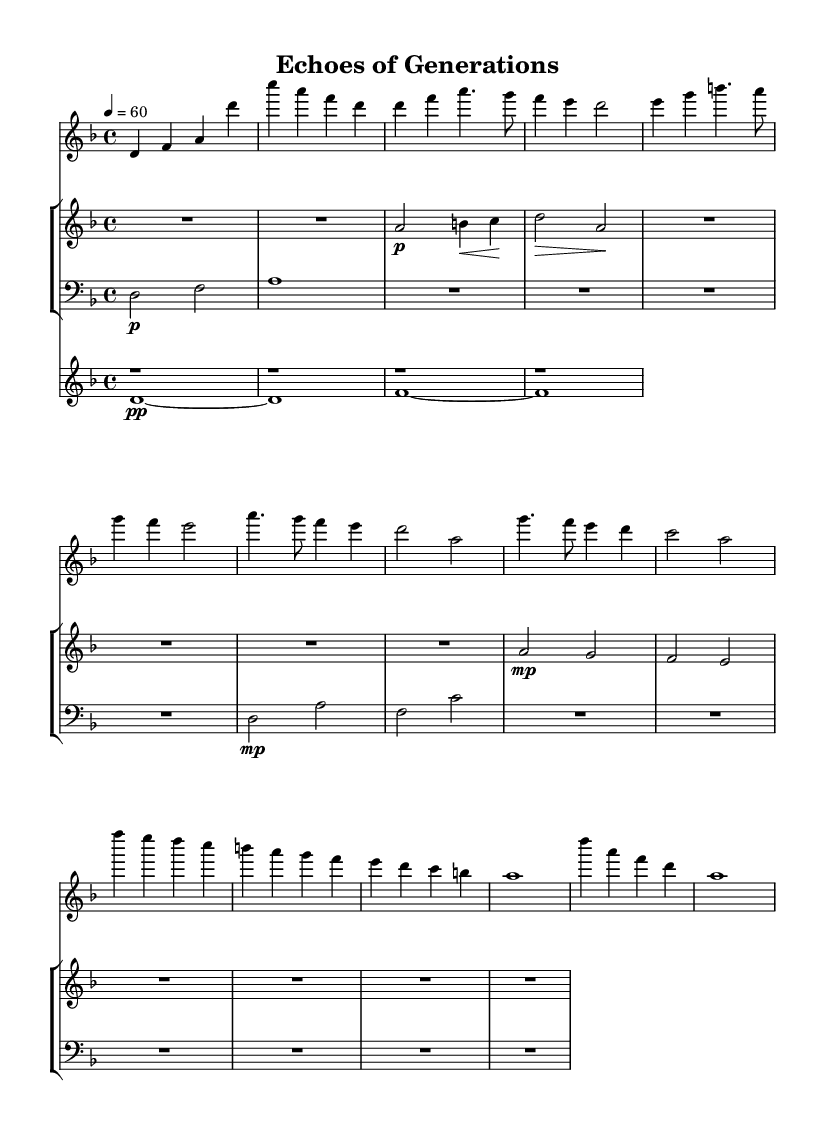What is the key signature of this music? The key signature is indicated by the presence of two flat symbols in the key signature section, which identifies it as D minor.
Answer: D minor What is the time signature of this music? The time signature is found at the beginning and indicated as 4/4, meaning there are four beats in a measure.
Answer: 4/4 What is the tempo marking for this piece? The tempo marking is shown by the number 60 and the quarter note indication, suggesting that there are 60 beats per minute.
Answer: 60 How many sections are there in the piece? The music is divided into distinct sections for the piano, violin, cello, and synth, evident from the score layout.
Answer: Four What dynamic markings are present in the violin part? The violin section shows varying dynamics, including a piano marking at the start and a crescent symbol indicating crescendo, reflecting a climactic building of sound.
Answer: Piano, crescendo Which instrument plays the sustained note sections? The synth is responsible for the sustained notes, as indicated by the presence of whole rests and long duration notes in its part, allowing for ambient layering.
Answer: Synth What is the longest note duration found in the cello part? The cello part features a whole note that spans the entire measure, easy to identify as it is drawn without additional flags or stems.
Answer: Whole note 